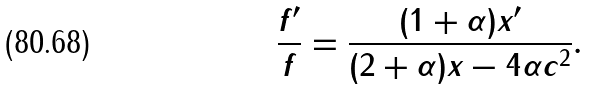Convert formula to latex. <formula><loc_0><loc_0><loc_500><loc_500>\frac { f ^ { \prime } } { f } = \frac { ( 1 + \alpha ) x ^ { \prime } } { ( 2 + \alpha ) x - 4 \alpha c ^ { 2 } } .</formula> 